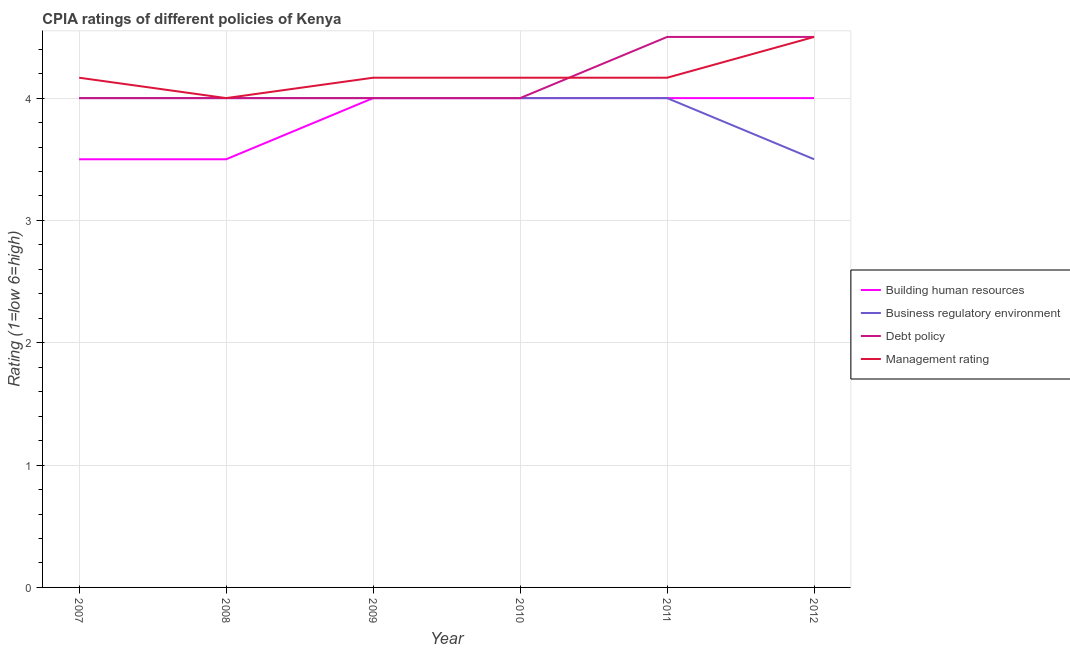How many different coloured lines are there?
Your answer should be compact. 4. Does the line corresponding to cpia rating of building human resources intersect with the line corresponding to cpia rating of business regulatory environment?
Offer a terse response. Yes. What is the cpia rating of management in 2010?
Offer a very short reply. 4.17. Across all years, what is the maximum cpia rating of management?
Your response must be concise. 4.5. Across all years, what is the minimum cpia rating of business regulatory environment?
Provide a short and direct response. 3.5. What is the total cpia rating of debt policy in the graph?
Provide a short and direct response. 25. What is the difference between the cpia rating of management in 2008 and that in 2010?
Your answer should be compact. -0.17. What is the difference between the cpia rating of management in 2011 and the cpia rating of building human resources in 2010?
Offer a very short reply. 0.17. What is the average cpia rating of management per year?
Provide a succinct answer. 4.19. In the year 2010, what is the difference between the cpia rating of management and cpia rating of building human resources?
Your answer should be very brief. 0.17. What is the ratio of the cpia rating of debt policy in 2007 to that in 2011?
Ensure brevity in your answer.  0.89. Is the cpia rating of building human resources in 2009 less than that in 2010?
Make the answer very short. No. Is the difference between the cpia rating of building human resources in 2010 and 2012 greater than the difference between the cpia rating of business regulatory environment in 2010 and 2012?
Provide a succinct answer. No. What is the difference between the highest and the second highest cpia rating of management?
Offer a terse response. 0.33. Is it the case that in every year, the sum of the cpia rating of building human resources and cpia rating of business regulatory environment is greater than the cpia rating of debt policy?
Your answer should be compact. Yes. Is the cpia rating of management strictly greater than the cpia rating of business regulatory environment over the years?
Offer a terse response. No. Is the cpia rating of business regulatory environment strictly less than the cpia rating of management over the years?
Provide a short and direct response. No. Are the values on the major ticks of Y-axis written in scientific E-notation?
Give a very brief answer. No. Does the graph contain any zero values?
Provide a succinct answer. No. Does the graph contain grids?
Give a very brief answer. Yes. How many legend labels are there?
Your answer should be very brief. 4. How are the legend labels stacked?
Your answer should be very brief. Vertical. What is the title of the graph?
Your answer should be very brief. CPIA ratings of different policies of Kenya. Does "Agricultural land" appear as one of the legend labels in the graph?
Provide a short and direct response. No. What is the Rating (1=low 6=high) of Building human resources in 2007?
Offer a very short reply. 3.5. What is the Rating (1=low 6=high) of Debt policy in 2007?
Offer a very short reply. 4. What is the Rating (1=low 6=high) in Management rating in 2007?
Provide a short and direct response. 4.17. What is the Rating (1=low 6=high) of Building human resources in 2008?
Ensure brevity in your answer.  3.5. What is the Rating (1=low 6=high) in Debt policy in 2008?
Provide a succinct answer. 4. What is the Rating (1=low 6=high) of Building human resources in 2009?
Ensure brevity in your answer.  4. What is the Rating (1=low 6=high) of Management rating in 2009?
Offer a terse response. 4.17. What is the Rating (1=low 6=high) of Building human resources in 2010?
Offer a terse response. 4. What is the Rating (1=low 6=high) of Business regulatory environment in 2010?
Offer a very short reply. 4. What is the Rating (1=low 6=high) in Debt policy in 2010?
Provide a short and direct response. 4. What is the Rating (1=low 6=high) in Management rating in 2010?
Your answer should be very brief. 4.17. What is the Rating (1=low 6=high) in Building human resources in 2011?
Your answer should be very brief. 4. What is the Rating (1=low 6=high) of Business regulatory environment in 2011?
Give a very brief answer. 4. What is the Rating (1=low 6=high) in Management rating in 2011?
Make the answer very short. 4.17. What is the Rating (1=low 6=high) of Building human resources in 2012?
Your answer should be very brief. 4. What is the Rating (1=low 6=high) in Debt policy in 2012?
Offer a terse response. 4.5. Across all years, what is the maximum Rating (1=low 6=high) of Building human resources?
Provide a short and direct response. 4. Across all years, what is the maximum Rating (1=low 6=high) in Business regulatory environment?
Provide a short and direct response. 4. Across all years, what is the maximum Rating (1=low 6=high) of Management rating?
Offer a terse response. 4.5. Across all years, what is the minimum Rating (1=low 6=high) of Building human resources?
Give a very brief answer. 3.5. Across all years, what is the minimum Rating (1=low 6=high) of Business regulatory environment?
Give a very brief answer. 3.5. Across all years, what is the minimum Rating (1=low 6=high) of Debt policy?
Ensure brevity in your answer.  4. Across all years, what is the minimum Rating (1=low 6=high) of Management rating?
Make the answer very short. 4. What is the total Rating (1=low 6=high) of Building human resources in the graph?
Give a very brief answer. 23. What is the total Rating (1=low 6=high) of Business regulatory environment in the graph?
Your answer should be very brief. 23.5. What is the total Rating (1=low 6=high) in Debt policy in the graph?
Give a very brief answer. 25. What is the total Rating (1=low 6=high) in Management rating in the graph?
Your answer should be compact. 25.17. What is the difference between the Rating (1=low 6=high) in Building human resources in 2007 and that in 2008?
Make the answer very short. 0. What is the difference between the Rating (1=low 6=high) of Building human resources in 2007 and that in 2009?
Your answer should be compact. -0.5. What is the difference between the Rating (1=low 6=high) in Business regulatory environment in 2007 and that in 2009?
Offer a very short reply. 0. What is the difference between the Rating (1=low 6=high) in Management rating in 2007 and that in 2009?
Provide a succinct answer. 0. What is the difference between the Rating (1=low 6=high) of Building human resources in 2007 and that in 2010?
Give a very brief answer. -0.5. What is the difference between the Rating (1=low 6=high) in Business regulatory environment in 2007 and that in 2010?
Provide a succinct answer. 0. What is the difference between the Rating (1=low 6=high) in Debt policy in 2007 and that in 2010?
Ensure brevity in your answer.  0. What is the difference between the Rating (1=low 6=high) of Management rating in 2007 and that in 2010?
Ensure brevity in your answer.  0. What is the difference between the Rating (1=low 6=high) of Building human resources in 2007 and that in 2011?
Make the answer very short. -0.5. What is the difference between the Rating (1=low 6=high) in Business regulatory environment in 2007 and that in 2011?
Your answer should be compact. 0. What is the difference between the Rating (1=low 6=high) of Management rating in 2007 and that in 2011?
Your answer should be very brief. 0. What is the difference between the Rating (1=low 6=high) of Building human resources in 2007 and that in 2012?
Keep it short and to the point. -0.5. What is the difference between the Rating (1=low 6=high) in Debt policy in 2007 and that in 2012?
Provide a short and direct response. -0.5. What is the difference between the Rating (1=low 6=high) in Management rating in 2007 and that in 2012?
Provide a succinct answer. -0.33. What is the difference between the Rating (1=low 6=high) in Building human resources in 2008 and that in 2009?
Keep it short and to the point. -0.5. What is the difference between the Rating (1=low 6=high) of Management rating in 2008 and that in 2010?
Provide a short and direct response. -0.17. What is the difference between the Rating (1=low 6=high) in Business regulatory environment in 2008 and that in 2011?
Offer a very short reply. 0. What is the difference between the Rating (1=low 6=high) in Debt policy in 2008 and that in 2011?
Give a very brief answer. -0.5. What is the difference between the Rating (1=low 6=high) of Management rating in 2008 and that in 2011?
Ensure brevity in your answer.  -0.17. What is the difference between the Rating (1=low 6=high) in Debt policy in 2008 and that in 2012?
Ensure brevity in your answer.  -0.5. What is the difference between the Rating (1=low 6=high) of Management rating in 2008 and that in 2012?
Provide a succinct answer. -0.5. What is the difference between the Rating (1=low 6=high) of Building human resources in 2009 and that in 2010?
Provide a short and direct response. 0. What is the difference between the Rating (1=low 6=high) of Business regulatory environment in 2009 and that in 2010?
Provide a short and direct response. 0. What is the difference between the Rating (1=low 6=high) in Debt policy in 2009 and that in 2010?
Give a very brief answer. 0. What is the difference between the Rating (1=low 6=high) in Management rating in 2009 and that in 2010?
Keep it short and to the point. 0. What is the difference between the Rating (1=low 6=high) of Building human resources in 2009 and that in 2011?
Offer a very short reply. 0. What is the difference between the Rating (1=low 6=high) in Business regulatory environment in 2009 and that in 2011?
Provide a succinct answer. 0. What is the difference between the Rating (1=low 6=high) in Building human resources in 2009 and that in 2012?
Offer a terse response. 0. What is the difference between the Rating (1=low 6=high) of Business regulatory environment in 2009 and that in 2012?
Provide a short and direct response. 0.5. What is the difference between the Rating (1=low 6=high) of Management rating in 2009 and that in 2012?
Give a very brief answer. -0.33. What is the difference between the Rating (1=low 6=high) of Management rating in 2010 and that in 2011?
Offer a very short reply. 0. What is the difference between the Rating (1=low 6=high) in Building human resources in 2010 and that in 2012?
Your answer should be very brief. 0. What is the difference between the Rating (1=low 6=high) in Business regulatory environment in 2010 and that in 2012?
Provide a short and direct response. 0.5. What is the difference between the Rating (1=low 6=high) of Debt policy in 2010 and that in 2012?
Make the answer very short. -0.5. What is the difference between the Rating (1=low 6=high) of Management rating in 2010 and that in 2012?
Offer a very short reply. -0.33. What is the difference between the Rating (1=low 6=high) in Business regulatory environment in 2011 and that in 2012?
Offer a very short reply. 0.5. What is the difference between the Rating (1=low 6=high) in Management rating in 2011 and that in 2012?
Keep it short and to the point. -0.33. What is the difference between the Rating (1=low 6=high) in Building human resources in 2007 and the Rating (1=low 6=high) in Business regulatory environment in 2008?
Your response must be concise. -0.5. What is the difference between the Rating (1=low 6=high) of Business regulatory environment in 2007 and the Rating (1=low 6=high) of Management rating in 2008?
Provide a short and direct response. 0. What is the difference between the Rating (1=low 6=high) in Debt policy in 2007 and the Rating (1=low 6=high) in Management rating in 2008?
Your response must be concise. 0. What is the difference between the Rating (1=low 6=high) of Building human resources in 2007 and the Rating (1=low 6=high) of Debt policy in 2009?
Provide a succinct answer. -0.5. What is the difference between the Rating (1=low 6=high) in Building human resources in 2007 and the Rating (1=low 6=high) in Management rating in 2009?
Offer a very short reply. -0.67. What is the difference between the Rating (1=low 6=high) of Business regulatory environment in 2007 and the Rating (1=low 6=high) of Debt policy in 2009?
Offer a very short reply. 0. What is the difference between the Rating (1=low 6=high) of Building human resources in 2007 and the Rating (1=low 6=high) of Management rating in 2010?
Ensure brevity in your answer.  -0.67. What is the difference between the Rating (1=low 6=high) of Building human resources in 2007 and the Rating (1=low 6=high) of Business regulatory environment in 2011?
Ensure brevity in your answer.  -0.5. What is the difference between the Rating (1=low 6=high) of Building human resources in 2007 and the Rating (1=low 6=high) of Management rating in 2011?
Your answer should be compact. -0.67. What is the difference between the Rating (1=low 6=high) of Building human resources in 2007 and the Rating (1=low 6=high) of Business regulatory environment in 2012?
Offer a terse response. 0. What is the difference between the Rating (1=low 6=high) of Building human resources in 2007 and the Rating (1=low 6=high) of Management rating in 2012?
Offer a terse response. -1. What is the difference between the Rating (1=low 6=high) of Debt policy in 2007 and the Rating (1=low 6=high) of Management rating in 2012?
Ensure brevity in your answer.  -0.5. What is the difference between the Rating (1=low 6=high) of Building human resources in 2008 and the Rating (1=low 6=high) of Debt policy in 2009?
Provide a succinct answer. -0.5. What is the difference between the Rating (1=low 6=high) in Building human resources in 2008 and the Rating (1=low 6=high) in Management rating in 2009?
Your response must be concise. -0.67. What is the difference between the Rating (1=low 6=high) of Business regulatory environment in 2008 and the Rating (1=low 6=high) of Management rating in 2009?
Your answer should be very brief. -0.17. What is the difference between the Rating (1=low 6=high) of Debt policy in 2008 and the Rating (1=low 6=high) of Management rating in 2009?
Ensure brevity in your answer.  -0.17. What is the difference between the Rating (1=low 6=high) in Building human resources in 2008 and the Rating (1=low 6=high) in Business regulatory environment in 2010?
Keep it short and to the point. -0.5. What is the difference between the Rating (1=low 6=high) in Building human resources in 2008 and the Rating (1=low 6=high) in Debt policy in 2010?
Give a very brief answer. -0.5. What is the difference between the Rating (1=low 6=high) of Building human resources in 2008 and the Rating (1=low 6=high) of Management rating in 2010?
Provide a short and direct response. -0.67. What is the difference between the Rating (1=low 6=high) in Business regulatory environment in 2008 and the Rating (1=low 6=high) in Management rating in 2010?
Offer a very short reply. -0.17. What is the difference between the Rating (1=low 6=high) in Building human resources in 2008 and the Rating (1=low 6=high) in Business regulatory environment in 2011?
Provide a short and direct response. -0.5. What is the difference between the Rating (1=low 6=high) in Business regulatory environment in 2008 and the Rating (1=low 6=high) in Management rating in 2011?
Keep it short and to the point. -0.17. What is the difference between the Rating (1=low 6=high) in Building human resources in 2008 and the Rating (1=low 6=high) in Business regulatory environment in 2012?
Ensure brevity in your answer.  0. What is the difference between the Rating (1=low 6=high) of Building human resources in 2008 and the Rating (1=low 6=high) of Debt policy in 2012?
Offer a very short reply. -1. What is the difference between the Rating (1=low 6=high) of Business regulatory environment in 2008 and the Rating (1=low 6=high) of Management rating in 2012?
Give a very brief answer. -0.5. What is the difference between the Rating (1=low 6=high) in Business regulatory environment in 2009 and the Rating (1=low 6=high) in Debt policy in 2010?
Provide a succinct answer. 0. What is the difference between the Rating (1=low 6=high) of Building human resources in 2009 and the Rating (1=low 6=high) of Business regulatory environment in 2011?
Your answer should be compact. 0. What is the difference between the Rating (1=low 6=high) of Building human resources in 2009 and the Rating (1=low 6=high) of Debt policy in 2011?
Provide a short and direct response. -0.5. What is the difference between the Rating (1=low 6=high) of Building human resources in 2009 and the Rating (1=low 6=high) of Management rating in 2011?
Make the answer very short. -0.17. What is the difference between the Rating (1=low 6=high) of Business regulatory environment in 2009 and the Rating (1=low 6=high) of Management rating in 2011?
Give a very brief answer. -0.17. What is the difference between the Rating (1=low 6=high) of Debt policy in 2009 and the Rating (1=low 6=high) of Management rating in 2011?
Offer a very short reply. -0.17. What is the difference between the Rating (1=low 6=high) in Building human resources in 2009 and the Rating (1=low 6=high) in Business regulatory environment in 2012?
Provide a succinct answer. 0.5. What is the difference between the Rating (1=low 6=high) of Building human resources in 2009 and the Rating (1=low 6=high) of Debt policy in 2012?
Your response must be concise. -0.5. What is the difference between the Rating (1=low 6=high) of Business regulatory environment in 2009 and the Rating (1=low 6=high) of Management rating in 2012?
Give a very brief answer. -0.5. What is the difference between the Rating (1=low 6=high) of Debt policy in 2009 and the Rating (1=low 6=high) of Management rating in 2012?
Keep it short and to the point. -0.5. What is the difference between the Rating (1=low 6=high) of Building human resources in 2010 and the Rating (1=low 6=high) of Business regulatory environment in 2011?
Your answer should be very brief. 0. What is the difference between the Rating (1=low 6=high) in Building human resources in 2010 and the Rating (1=low 6=high) in Management rating in 2011?
Ensure brevity in your answer.  -0.17. What is the difference between the Rating (1=low 6=high) in Business regulatory environment in 2010 and the Rating (1=low 6=high) in Debt policy in 2011?
Your response must be concise. -0.5. What is the difference between the Rating (1=low 6=high) in Business regulatory environment in 2010 and the Rating (1=low 6=high) in Management rating in 2011?
Keep it short and to the point. -0.17. What is the difference between the Rating (1=low 6=high) in Debt policy in 2010 and the Rating (1=low 6=high) in Management rating in 2011?
Keep it short and to the point. -0.17. What is the difference between the Rating (1=low 6=high) of Building human resources in 2010 and the Rating (1=low 6=high) of Debt policy in 2012?
Keep it short and to the point. -0.5. What is the difference between the Rating (1=low 6=high) of Business regulatory environment in 2010 and the Rating (1=low 6=high) of Debt policy in 2012?
Provide a succinct answer. -0.5. What is the difference between the Rating (1=low 6=high) of Business regulatory environment in 2010 and the Rating (1=low 6=high) of Management rating in 2012?
Keep it short and to the point. -0.5. What is the difference between the Rating (1=low 6=high) in Debt policy in 2010 and the Rating (1=low 6=high) in Management rating in 2012?
Your answer should be compact. -0.5. What is the difference between the Rating (1=low 6=high) of Building human resources in 2011 and the Rating (1=low 6=high) of Business regulatory environment in 2012?
Your response must be concise. 0.5. What is the difference between the Rating (1=low 6=high) of Building human resources in 2011 and the Rating (1=low 6=high) of Management rating in 2012?
Keep it short and to the point. -0.5. What is the average Rating (1=low 6=high) in Building human resources per year?
Make the answer very short. 3.83. What is the average Rating (1=low 6=high) in Business regulatory environment per year?
Your answer should be very brief. 3.92. What is the average Rating (1=low 6=high) in Debt policy per year?
Provide a short and direct response. 4.17. What is the average Rating (1=low 6=high) of Management rating per year?
Offer a very short reply. 4.19. In the year 2007, what is the difference between the Rating (1=low 6=high) of Building human resources and Rating (1=low 6=high) of Business regulatory environment?
Your answer should be compact. -0.5. In the year 2007, what is the difference between the Rating (1=low 6=high) of Debt policy and Rating (1=low 6=high) of Management rating?
Make the answer very short. -0.17. In the year 2008, what is the difference between the Rating (1=low 6=high) of Building human resources and Rating (1=low 6=high) of Business regulatory environment?
Your answer should be very brief. -0.5. In the year 2008, what is the difference between the Rating (1=low 6=high) in Building human resources and Rating (1=low 6=high) in Debt policy?
Give a very brief answer. -0.5. In the year 2008, what is the difference between the Rating (1=low 6=high) of Building human resources and Rating (1=low 6=high) of Management rating?
Provide a short and direct response. -0.5. In the year 2008, what is the difference between the Rating (1=low 6=high) in Debt policy and Rating (1=low 6=high) in Management rating?
Your response must be concise. 0. In the year 2009, what is the difference between the Rating (1=low 6=high) of Building human resources and Rating (1=low 6=high) of Business regulatory environment?
Make the answer very short. 0. In the year 2009, what is the difference between the Rating (1=low 6=high) in Building human resources and Rating (1=low 6=high) in Debt policy?
Your response must be concise. 0. In the year 2009, what is the difference between the Rating (1=low 6=high) of Debt policy and Rating (1=low 6=high) of Management rating?
Provide a succinct answer. -0.17. In the year 2010, what is the difference between the Rating (1=low 6=high) of Building human resources and Rating (1=low 6=high) of Debt policy?
Provide a succinct answer. 0. In the year 2010, what is the difference between the Rating (1=low 6=high) in Building human resources and Rating (1=low 6=high) in Management rating?
Ensure brevity in your answer.  -0.17. In the year 2011, what is the difference between the Rating (1=low 6=high) in Building human resources and Rating (1=low 6=high) in Debt policy?
Give a very brief answer. -0.5. In the year 2012, what is the difference between the Rating (1=low 6=high) in Building human resources and Rating (1=low 6=high) in Business regulatory environment?
Your answer should be very brief. 0.5. In the year 2012, what is the difference between the Rating (1=low 6=high) of Building human resources and Rating (1=low 6=high) of Management rating?
Keep it short and to the point. -0.5. In the year 2012, what is the difference between the Rating (1=low 6=high) in Business regulatory environment and Rating (1=low 6=high) in Debt policy?
Provide a short and direct response. -1. In the year 2012, what is the difference between the Rating (1=low 6=high) of Business regulatory environment and Rating (1=low 6=high) of Management rating?
Your answer should be very brief. -1. What is the ratio of the Rating (1=low 6=high) of Building human resources in 2007 to that in 2008?
Your response must be concise. 1. What is the ratio of the Rating (1=low 6=high) in Debt policy in 2007 to that in 2008?
Offer a terse response. 1. What is the ratio of the Rating (1=low 6=high) of Management rating in 2007 to that in 2008?
Your answer should be very brief. 1.04. What is the ratio of the Rating (1=low 6=high) in Building human resources in 2007 to that in 2009?
Your response must be concise. 0.88. What is the ratio of the Rating (1=low 6=high) of Business regulatory environment in 2007 to that in 2009?
Offer a terse response. 1. What is the ratio of the Rating (1=low 6=high) of Debt policy in 2007 to that in 2009?
Provide a short and direct response. 1. What is the ratio of the Rating (1=low 6=high) in Management rating in 2007 to that in 2009?
Make the answer very short. 1. What is the ratio of the Rating (1=low 6=high) of Building human resources in 2007 to that in 2011?
Offer a terse response. 0.88. What is the ratio of the Rating (1=low 6=high) in Business regulatory environment in 2007 to that in 2011?
Your answer should be compact. 1. What is the ratio of the Rating (1=low 6=high) in Debt policy in 2007 to that in 2011?
Give a very brief answer. 0.89. What is the ratio of the Rating (1=low 6=high) in Building human resources in 2007 to that in 2012?
Your response must be concise. 0.88. What is the ratio of the Rating (1=low 6=high) in Business regulatory environment in 2007 to that in 2012?
Provide a short and direct response. 1.14. What is the ratio of the Rating (1=low 6=high) of Debt policy in 2007 to that in 2012?
Your answer should be compact. 0.89. What is the ratio of the Rating (1=low 6=high) of Management rating in 2007 to that in 2012?
Your answer should be very brief. 0.93. What is the ratio of the Rating (1=low 6=high) of Debt policy in 2008 to that in 2009?
Keep it short and to the point. 1. What is the ratio of the Rating (1=low 6=high) of Business regulatory environment in 2008 to that in 2010?
Ensure brevity in your answer.  1. What is the ratio of the Rating (1=low 6=high) of Debt policy in 2008 to that in 2010?
Make the answer very short. 1. What is the ratio of the Rating (1=low 6=high) of Business regulatory environment in 2008 to that in 2011?
Provide a short and direct response. 1. What is the ratio of the Rating (1=low 6=high) of Debt policy in 2008 to that in 2012?
Your response must be concise. 0.89. What is the ratio of the Rating (1=low 6=high) in Management rating in 2008 to that in 2012?
Give a very brief answer. 0.89. What is the ratio of the Rating (1=low 6=high) in Business regulatory environment in 2009 to that in 2010?
Give a very brief answer. 1. What is the ratio of the Rating (1=low 6=high) of Debt policy in 2009 to that in 2010?
Give a very brief answer. 1. What is the ratio of the Rating (1=low 6=high) of Building human resources in 2009 to that in 2011?
Offer a terse response. 1. What is the ratio of the Rating (1=low 6=high) in Business regulatory environment in 2009 to that in 2011?
Make the answer very short. 1. What is the ratio of the Rating (1=low 6=high) of Debt policy in 2009 to that in 2011?
Give a very brief answer. 0.89. What is the ratio of the Rating (1=low 6=high) in Management rating in 2009 to that in 2011?
Provide a succinct answer. 1. What is the ratio of the Rating (1=low 6=high) of Management rating in 2009 to that in 2012?
Keep it short and to the point. 0.93. What is the ratio of the Rating (1=low 6=high) of Debt policy in 2010 to that in 2011?
Your answer should be very brief. 0.89. What is the ratio of the Rating (1=low 6=high) of Business regulatory environment in 2010 to that in 2012?
Provide a succinct answer. 1.14. What is the ratio of the Rating (1=low 6=high) of Debt policy in 2010 to that in 2012?
Your answer should be very brief. 0.89. What is the ratio of the Rating (1=low 6=high) of Management rating in 2010 to that in 2012?
Give a very brief answer. 0.93. What is the ratio of the Rating (1=low 6=high) of Business regulatory environment in 2011 to that in 2012?
Your answer should be very brief. 1.14. What is the ratio of the Rating (1=low 6=high) in Debt policy in 2011 to that in 2012?
Offer a terse response. 1. What is the ratio of the Rating (1=low 6=high) in Management rating in 2011 to that in 2012?
Provide a short and direct response. 0.93. What is the difference between the highest and the second highest Rating (1=low 6=high) of Building human resources?
Give a very brief answer. 0. What is the difference between the highest and the second highest Rating (1=low 6=high) of Debt policy?
Your response must be concise. 0. What is the difference between the highest and the second highest Rating (1=low 6=high) in Management rating?
Keep it short and to the point. 0.33. What is the difference between the highest and the lowest Rating (1=low 6=high) of Business regulatory environment?
Your response must be concise. 0.5. What is the difference between the highest and the lowest Rating (1=low 6=high) in Debt policy?
Offer a very short reply. 0.5. 